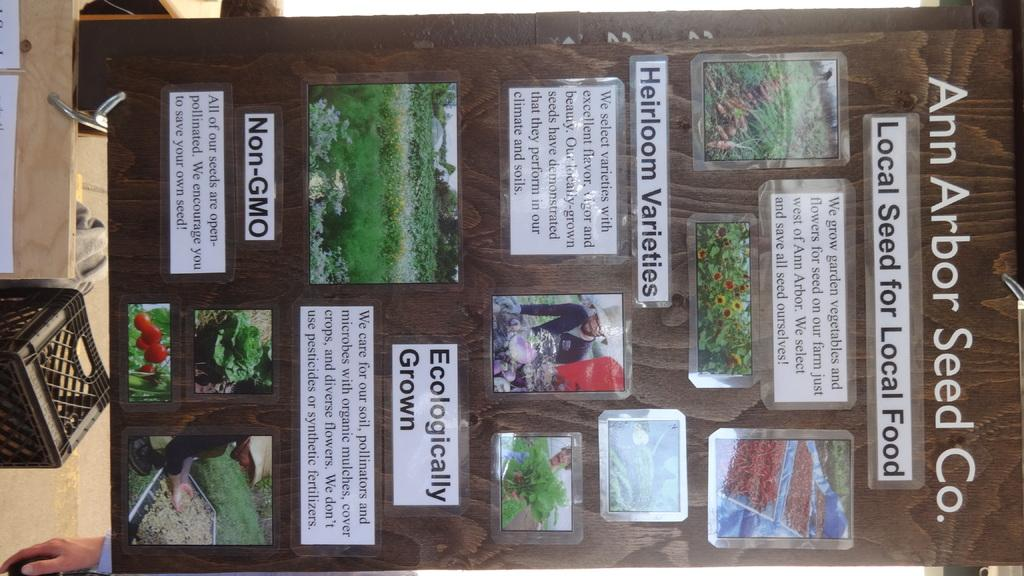<image>
Write a terse but informative summary of the picture. A poster from Ann Arbor Seed Co. shows the lifecycle of their seeds 